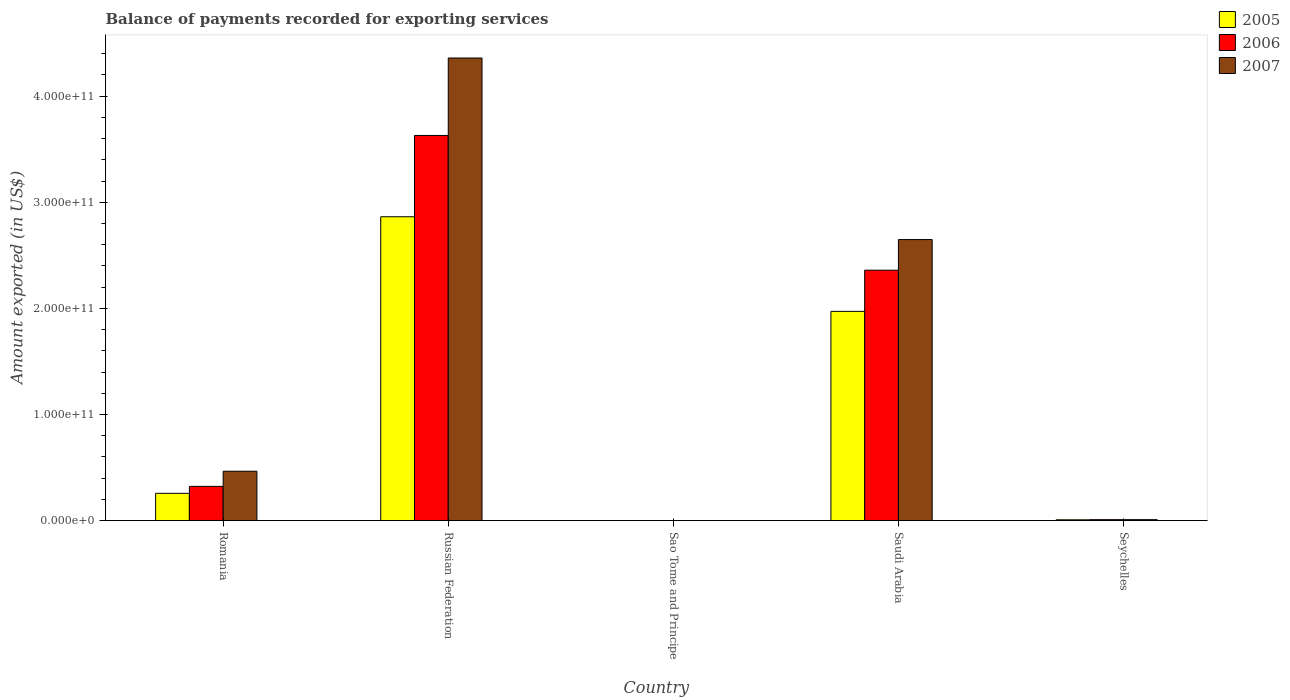How many different coloured bars are there?
Your answer should be very brief. 3. Are the number of bars per tick equal to the number of legend labels?
Make the answer very short. Yes. How many bars are there on the 1st tick from the left?
Provide a short and direct response. 3. What is the label of the 4th group of bars from the left?
Your answer should be compact. Saudi Arabia. What is the amount exported in 2005 in Russian Federation?
Provide a succinct answer. 2.86e+11. Across all countries, what is the maximum amount exported in 2007?
Give a very brief answer. 4.36e+11. Across all countries, what is the minimum amount exported in 2005?
Keep it short and to the point. 1.79e+07. In which country was the amount exported in 2005 maximum?
Keep it short and to the point. Russian Federation. In which country was the amount exported in 2005 minimum?
Keep it short and to the point. Sao Tome and Principe. What is the total amount exported in 2005 in the graph?
Make the answer very short. 5.10e+11. What is the difference between the amount exported in 2006 in Romania and that in Seychelles?
Offer a terse response. 3.14e+1. What is the difference between the amount exported in 2006 in Saudi Arabia and the amount exported in 2007 in Sao Tome and Principe?
Keep it short and to the point. 2.36e+11. What is the average amount exported in 2006 per country?
Keep it short and to the point. 1.26e+11. What is the difference between the amount exported of/in 2006 and amount exported of/in 2005 in Russian Federation?
Your answer should be compact. 7.66e+1. What is the ratio of the amount exported in 2005 in Romania to that in Saudi Arabia?
Offer a terse response. 0.13. Is the difference between the amount exported in 2006 in Romania and Seychelles greater than the difference between the amount exported in 2005 in Romania and Seychelles?
Provide a succinct answer. Yes. What is the difference between the highest and the second highest amount exported in 2006?
Your response must be concise. -3.31e+11. What is the difference between the highest and the lowest amount exported in 2007?
Provide a short and direct response. 4.36e+11. Is the sum of the amount exported in 2006 in Sao Tome and Principe and Seychelles greater than the maximum amount exported in 2007 across all countries?
Ensure brevity in your answer.  No. How many bars are there?
Your answer should be very brief. 15. What is the difference between two consecutive major ticks on the Y-axis?
Your answer should be very brief. 1.00e+11. Does the graph contain any zero values?
Give a very brief answer. No. How many legend labels are there?
Provide a short and direct response. 3. How are the legend labels stacked?
Ensure brevity in your answer.  Vertical. What is the title of the graph?
Provide a short and direct response. Balance of payments recorded for exporting services. Does "2009" appear as one of the legend labels in the graph?
Offer a very short reply. No. What is the label or title of the Y-axis?
Your response must be concise. Amount exported (in US$). What is the Amount exported (in US$) of 2005 in Romania?
Give a very brief answer. 2.57e+1. What is the Amount exported (in US$) in 2006 in Romania?
Ensure brevity in your answer.  3.22e+1. What is the Amount exported (in US$) of 2007 in Romania?
Your response must be concise. 4.65e+1. What is the Amount exported (in US$) in 2005 in Russian Federation?
Provide a short and direct response. 2.86e+11. What is the Amount exported (in US$) of 2006 in Russian Federation?
Make the answer very short. 3.63e+11. What is the Amount exported (in US$) of 2007 in Russian Federation?
Offer a very short reply. 4.36e+11. What is the Amount exported (in US$) of 2005 in Sao Tome and Principe?
Give a very brief answer. 1.79e+07. What is the Amount exported (in US$) of 2006 in Sao Tome and Principe?
Offer a terse response. 2.23e+07. What is the Amount exported (in US$) of 2007 in Sao Tome and Principe?
Offer a very short reply. 2.03e+07. What is the Amount exported (in US$) in 2005 in Saudi Arabia?
Give a very brief answer. 1.97e+11. What is the Amount exported (in US$) of 2006 in Saudi Arabia?
Your response must be concise. 2.36e+11. What is the Amount exported (in US$) in 2007 in Saudi Arabia?
Ensure brevity in your answer.  2.65e+11. What is the Amount exported (in US$) of 2005 in Seychelles?
Your response must be concise. 7.29e+08. What is the Amount exported (in US$) in 2006 in Seychelles?
Offer a terse response. 8.61e+08. What is the Amount exported (in US$) of 2007 in Seychelles?
Keep it short and to the point. 8.57e+08. Across all countries, what is the maximum Amount exported (in US$) in 2005?
Offer a terse response. 2.86e+11. Across all countries, what is the maximum Amount exported (in US$) of 2006?
Your response must be concise. 3.63e+11. Across all countries, what is the maximum Amount exported (in US$) in 2007?
Your answer should be compact. 4.36e+11. Across all countries, what is the minimum Amount exported (in US$) in 2005?
Ensure brevity in your answer.  1.79e+07. Across all countries, what is the minimum Amount exported (in US$) in 2006?
Make the answer very short. 2.23e+07. Across all countries, what is the minimum Amount exported (in US$) of 2007?
Ensure brevity in your answer.  2.03e+07. What is the total Amount exported (in US$) in 2005 in the graph?
Give a very brief answer. 5.10e+11. What is the total Amount exported (in US$) of 2006 in the graph?
Offer a very short reply. 6.32e+11. What is the total Amount exported (in US$) in 2007 in the graph?
Ensure brevity in your answer.  7.48e+11. What is the difference between the Amount exported (in US$) in 2005 in Romania and that in Russian Federation?
Offer a very short reply. -2.61e+11. What is the difference between the Amount exported (in US$) of 2006 in Romania and that in Russian Federation?
Your response must be concise. -3.31e+11. What is the difference between the Amount exported (in US$) of 2007 in Romania and that in Russian Federation?
Offer a very short reply. -3.89e+11. What is the difference between the Amount exported (in US$) in 2005 in Romania and that in Sao Tome and Principe?
Provide a short and direct response. 2.57e+1. What is the difference between the Amount exported (in US$) of 2006 in Romania and that in Sao Tome and Principe?
Offer a terse response. 3.22e+1. What is the difference between the Amount exported (in US$) in 2007 in Romania and that in Sao Tome and Principe?
Offer a terse response. 4.65e+1. What is the difference between the Amount exported (in US$) in 2005 in Romania and that in Saudi Arabia?
Your response must be concise. -1.71e+11. What is the difference between the Amount exported (in US$) of 2006 in Romania and that in Saudi Arabia?
Your response must be concise. -2.04e+11. What is the difference between the Amount exported (in US$) in 2007 in Romania and that in Saudi Arabia?
Provide a succinct answer. -2.18e+11. What is the difference between the Amount exported (in US$) in 2005 in Romania and that in Seychelles?
Keep it short and to the point. 2.50e+1. What is the difference between the Amount exported (in US$) of 2006 in Romania and that in Seychelles?
Offer a terse response. 3.14e+1. What is the difference between the Amount exported (in US$) in 2007 in Romania and that in Seychelles?
Offer a very short reply. 4.57e+1. What is the difference between the Amount exported (in US$) of 2005 in Russian Federation and that in Sao Tome and Principe?
Your answer should be compact. 2.86e+11. What is the difference between the Amount exported (in US$) of 2006 in Russian Federation and that in Sao Tome and Principe?
Your response must be concise. 3.63e+11. What is the difference between the Amount exported (in US$) of 2007 in Russian Federation and that in Sao Tome and Principe?
Your response must be concise. 4.36e+11. What is the difference between the Amount exported (in US$) of 2005 in Russian Federation and that in Saudi Arabia?
Give a very brief answer. 8.92e+1. What is the difference between the Amount exported (in US$) of 2006 in Russian Federation and that in Saudi Arabia?
Your response must be concise. 1.27e+11. What is the difference between the Amount exported (in US$) of 2007 in Russian Federation and that in Saudi Arabia?
Keep it short and to the point. 1.71e+11. What is the difference between the Amount exported (in US$) in 2005 in Russian Federation and that in Seychelles?
Ensure brevity in your answer.  2.86e+11. What is the difference between the Amount exported (in US$) in 2006 in Russian Federation and that in Seychelles?
Give a very brief answer. 3.62e+11. What is the difference between the Amount exported (in US$) in 2007 in Russian Federation and that in Seychelles?
Your response must be concise. 4.35e+11. What is the difference between the Amount exported (in US$) in 2005 in Sao Tome and Principe and that in Saudi Arabia?
Provide a short and direct response. -1.97e+11. What is the difference between the Amount exported (in US$) in 2006 in Sao Tome and Principe and that in Saudi Arabia?
Provide a short and direct response. -2.36e+11. What is the difference between the Amount exported (in US$) in 2007 in Sao Tome and Principe and that in Saudi Arabia?
Offer a very short reply. -2.65e+11. What is the difference between the Amount exported (in US$) of 2005 in Sao Tome and Principe and that in Seychelles?
Offer a very short reply. -7.12e+08. What is the difference between the Amount exported (in US$) in 2006 in Sao Tome and Principe and that in Seychelles?
Your response must be concise. -8.38e+08. What is the difference between the Amount exported (in US$) in 2007 in Sao Tome and Principe and that in Seychelles?
Make the answer very short. -8.37e+08. What is the difference between the Amount exported (in US$) in 2005 in Saudi Arabia and that in Seychelles?
Ensure brevity in your answer.  1.96e+11. What is the difference between the Amount exported (in US$) of 2006 in Saudi Arabia and that in Seychelles?
Offer a terse response. 2.35e+11. What is the difference between the Amount exported (in US$) of 2007 in Saudi Arabia and that in Seychelles?
Your answer should be compact. 2.64e+11. What is the difference between the Amount exported (in US$) in 2005 in Romania and the Amount exported (in US$) in 2006 in Russian Federation?
Your answer should be compact. -3.37e+11. What is the difference between the Amount exported (in US$) in 2005 in Romania and the Amount exported (in US$) in 2007 in Russian Federation?
Your answer should be very brief. -4.10e+11. What is the difference between the Amount exported (in US$) in 2006 in Romania and the Amount exported (in US$) in 2007 in Russian Federation?
Offer a terse response. -4.04e+11. What is the difference between the Amount exported (in US$) in 2005 in Romania and the Amount exported (in US$) in 2006 in Sao Tome and Principe?
Ensure brevity in your answer.  2.57e+1. What is the difference between the Amount exported (in US$) in 2005 in Romania and the Amount exported (in US$) in 2007 in Sao Tome and Principe?
Give a very brief answer. 2.57e+1. What is the difference between the Amount exported (in US$) in 2006 in Romania and the Amount exported (in US$) in 2007 in Sao Tome and Principe?
Your response must be concise. 3.22e+1. What is the difference between the Amount exported (in US$) in 2005 in Romania and the Amount exported (in US$) in 2006 in Saudi Arabia?
Offer a terse response. -2.10e+11. What is the difference between the Amount exported (in US$) of 2005 in Romania and the Amount exported (in US$) of 2007 in Saudi Arabia?
Make the answer very short. -2.39e+11. What is the difference between the Amount exported (in US$) of 2006 in Romania and the Amount exported (in US$) of 2007 in Saudi Arabia?
Provide a short and direct response. -2.33e+11. What is the difference between the Amount exported (in US$) in 2005 in Romania and the Amount exported (in US$) in 2006 in Seychelles?
Your answer should be very brief. 2.48e+1. What is the difference between the Amount exported (in US$) in 2005 in Romania and the Amount exported (in US$) in 2007 in Seychelles?
Give a very brief answer. 2.48e+1. What is the difference between the Amount exported (in US$) of 2006 in Romania and the Amount exported (in US$) of 2007 in Seychelles?
Your answer should be very brief. 3.14e+1. What is the difference between the Amount exported (in US$) of 2005 in Russian Federation and the Amount exported (in US$) of 2006 in Sao Tome and Principe?
Provide a short and direct response. 2.86e+11. What is the difference between the Amount exported (in US$) in 2005 in Russian Federation and the Amount exported (in US$) in 2007 in Sao Tome and Principe?
Make the answer very short. 2.86e+11. What is the difference between the Amount exported (in US$) of 2006 in Russian Federation and the Amount exported (in US$) of 2007 in Sao Tome and Principe?
Give a very brief answer. 3.63e+11. What is the difference between the Amount exported (in US$) in 2005 in Russian Federation and the Amount exported (in US$) in 2006 in Saudi Arabia?
Provide a succinct answer. 5.04e+1. What is the difference between the Amount exported (in US$) of 2005 in Russian Federation and the Amount exported (in US$) of 2007 in Saudi Arabia?
Provide a succinct answer. 2.15e+1. What is the difference between the Amount exported (in US$) in 2006 in Russian Federation and the Amount exported (in US$) in 2007 in Saudi Arabia?
Provide a short and direct response. 9.81e+1. What is the difference between the Amount exported (in US$) in 2005 in Russian Federation and the Amount exported (in US$) in 2006 in Seychelles?
Provide a short and direct response. 2.85e+11. What is the difference between the Amount exported (in US$) of 2005 in Russian Federation and the Amount exported (in US$) of 2007 in Seychelles?
Provide a succinct answer. 2.85e+11. What is the difference between the Amount exported (in US$) of 2006 in Russian Federation and the Amount exported (in US$) of 2007 in Seychelles?
Offer a terse response. 3.62e+11. What is the difference between the Amount exported (in US$) of 2005 in Sao Tome and Principe and the Amount exported (in US$) of 2006 in Saudi Arabia?
Provide a short and direct response. -2.36e+11. What is the difference between the Amount exported (in US$) of 2005 in Sao Tome and Principe and the Amount exported (in US$) of 2007 in Saudi Arabia?
Your answer should be compact. -2.65e+11. What is the difference between the Amount exported (in US$) in 2006 in Sao Tome and Principe and the Amount exported (in US$) in 2007 in Saudi Arabia?
Give a very brief answer. -2.65e+11. What is the difference between the Amount exported (in US$) in 2005 in Sao Tome and Principe and the Amount exported (in US$) in 2006 in Seychelles?
Provide a short and direct response. -8.43e+08. What is the difference between the Amount exported (in US$) of 2005 in Sao Tome and Principe and the Amount exported (in US$) of 2007 in Seychelles?
Give a very brief answer. -8.39e+08. What is the difference between the Amount exported (in US$) of 2006 in Sao Tome and Principe and the Amount exported (in US$) of 2007 in Seychelles?
Offer a terse response. -8.35e+08. What is the difference between the Amount exported (in US$) in 2005 in Saudi Arabia and the Amount exported (in US$) in 2006 in Seychelles?
Give a very brief answer. 1.96e+11. What is the difference between the Amount exported (in US$) of 2005 in Saudi Arabia and the Amount exported (in US$) of 2007 in Seychelles?
Give a very brief answer. 1.96e+11. What is the difference between the Amount exported (in US$) of 2006 in Saudi Arabia and the Amount exported (in US$) of 2007 in Seychelles?
Your answer should be very brief. 2.35e+11. What is the average Amount exported (in US$) of 2005 per country?
Keep it short and to the point. 1.02e+11. What is the average Amount exported (in US$) in 2006 per country?
Offer a very short reply. 1.26e+11. What is the average Amount exported (in US$) in 2007 per country?
Keep it short and to the point. 1.50e+11. What is the difference between the Amount exported (in US$) of 2005 and Amount exported (in US$) of 2006 in Romania?
Ensure brevity in your answer.  -6.55e+09. What is the difference between the Amount exported (in US$) of 2005 and Amount exported (in US$) of 2007 in Romania?
Your answer should be compact. -2.08e+1. What is the difference between the Amount exported (in US$) of 2006 and Amount exported (in US$) of 2007 in Romania?
Make the answer very short. -1.43e+1. What is the difference between the Amount exported (in US$) of 2005 and Amount exported (in US$) of 2006 in Russian Federation?
Give a very brief answer. -7.66e+1. What is the difference between the Amount exported (in US$) in 2005 and Amount exported (in US$) in 2007 in Russian Federation?
Your answer should be compact. -1.50e+11. What is the difference between the Amount exported (in US$) of 2006 and Amount exported (in US$) of 2007 in Russian Federation?
Offer a very short reply. -7.30e+1. What is the difference between the Amount exported (in US$) in 2005 and Amount exported (in US$) in 2006 in Sao Tome and Principe?
Your answer should be compact. -4.35e+06. What is the difference between the Amount exported (in US$) of 2005 and Amount exported (in US$) of 2007 in Sao Tome and Principe?
Provide a short and direct response. -2.36e+06. What is the difference between the Amount exported (in US$) of 2006 and Amount exported (in US$) of 2007 in Sao Tome and Principe?
Ensure brevity in your answer.  1.99e+06. What is the difference between the Amount exported (in US$) in 2005 and Amount exported (in US$) in 2006 in Saudi Arabia?
Offer a terse response. -3.88e+1. What is the difference between the Amount exported (in US$) of 2005 and Amount exported (in US$) of 2007 in Saudi Arabia?
Offer a very short reply. -6.77e+1. What is the difference between the Amount exported (in US$) in 2006 and Amount exported (in US$) in 2007 in Saudi Arabia?
Offer a very short reply. -2.89e+1. What is the difference between the Amount exported (in US$) in 2005 and Amount exported (in US$) in 2006 in Seychelles?
Provide a succinct answer. -1.31e+08. What is the difference between the Amount exported (in US$) of 2005 and Amount exported (in US$) of 2007 in Seychelles?
Your answer should be compact. -1.28e+08. What is the difference between the Amount exported (in US$) in 2006 and Amount exported (in US$) in 2007 in Seychelles?
Provide a short and direct response. 3.32e+06. What is the ratio of the Amount exported (in US$) in 2005 in Romania to that in Russian Federation?
Offer a very short reply. 0.09. What is the ratio of the Amount exported (in US$) in 2006 in Romania to that in Russian Federation?
Provide a short and direct response. 0.09. What is the ratio of the Amount exported (in US$) of 2007 in Romania to that in Russian Federation?
Keep it short and to the point. 0.11. What is the ratio of the Amount exported (in US$) of 2005 in Romania to that in Sao Tome and Principe?
Give a very brief answer. 1434.23. What is the ratio of the Amount exported (in US$) in 2006 in Romania to that in Sao Tome and Principe?
Offer a very short reply. 1447.83. What is the ratio of the Amount exported (in US$) of 2007 in Romania to that in Sao Tome and Principe?
Your answer should be very brief. 2293.9. What is the ratio of the Amount exported (in US$) in 2005 in Romania to that in Saudi Arabia?
Provide a short and direct response. 0.13. What is the ratio of the Amount exported (in US$) of 2006 in Romania to that in Saudi Arabia?
Provide a short and direct response. 0.14. What is the ratio of the Amount exported (in US$) in 2007 in Romania to that in Saudi Arabia?
Keep it short and to the point. 0.18. What is the ratio of the Amount exported (in US$) in 2005 in Romania to that in Seychelles?
Offer a terse response. 35.22. What is the ratio of the Amount exported (in US$) in 2006 in Romania to that in Seychelles?
Your response must be concise. 37.46. What is the ratio of the Amount exported (in US$) in 2007 in Romania to that in Seychelles?
Give a very brief answer. 54.25. What is the ratio of the Amount exported (in US$) of 2005 in Russian Federation to that in Sao Tome and Principe?
Your response must be concise. 1.60e+04. What is the ratio of the Amount exported (in US$) in 2006 in Russian Federation to that in Sao Tome and Principe?
Make the answer very short. 1.63e+04. What is the ratio of the Amount exported (in US$) of 2007 in Russian Federation to that in Sao Tome and Principe?
Give a very brief answer. 2.15e+04. What is the ratio of the Amount exported (in US$) of 2005 in Russian Federation to that in Saudi Arabia?
Provide a succinct answer. 1.45. What is the ratio of the Amount exported (in US$) of 2006 in Russian Federation to that in Saudi Arabia?
Provide a short and direct response. 1.54. What is the ratio of the Amount exported (in US$) of 2007 in Russian Federation to that in Saudi Arabia?
Your answer should be compact. 1.65. What is the ratio of the Amount exported (in US$) of 2005 in Russian Federation to that in Seychelles?
Offer a terse response. 392.54. What is the ratio of the Amount exported (in US$) of 2006 in Russian Federation to that in Seychelles?
Your answer should be compact. 421.75. What is the ratio of the Amount exported (in US$) of 2007 in Russian Federation to that in Seychelles?
Offer a terse response. 508.54. What is the ratio of the Amount exported (in US$) of 2005 in Sao Tome and Principe to that in Saudi Arabia?
Offer a terse response. 0. What is the ratio of the Amount exported (in US$) in 2007 in Sao Tome and Principe to that in Saudi Arabia?
Your response must be concise. 0. What is the ratio of the Amount exported (in US$) of 2005 in Sao Tome and Principe to that in Seychelles?
Offer a very short reply. 0.02. What is the ratio of the Amount exported (in US$) of 2006 in Sao Tome and Principe to that in Seychelles?
Offer a very short reply. 0.03. What is the ratio of the Amount exported (in US$) of 2007 in Sao Tome and Principe to that in Seychelles?
Your answer should be compact. 0.02. What is the ratio of the Amount exported (in US$) in 2005 in Saudi Arabia to that in Seychelles?
Keep it short and to the point. 270.3. What is the ratio of the Amount exported (in US$) of 2006 in Saudi Arabia to that in Seychelles?
Make the answer very short. 274.2. What is the ratio of the Amount exported (in US$) in 2007 in Saudi Arabia to that in Seychelles?
Provide a succinct answer. 308.93. What is the difference between the highest and the second highest Amount exported (in US$) in 2005?
Ensure brevity in your answer.  8.92e+1. What is the difference between the highest and the second highest Amount exported (in US$) in 2006?
Your answer should be compact. 1.27e+11. What is the difference between the highest and the second highest Amount exported (in US$) of 2007?
Offer a terse response. 1.71e+11. What is the difference between the highest and the lowest Amount exported (in US$) in 2005?
Your answer should be compact. 2.86e+11. What is the difference between the highest and the lowest Amount exported (in US$) of 2006?
Offer a very short reply. 3.63e+11. What is the difference between the highest and the lowest Amount exported (in US$) in 2007?
Give a very brief answer. 4.36e+11. 